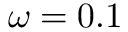<formula> <loc_0><loc_0><loc_500><loc_500>\omega = 0 . 1</formula> 